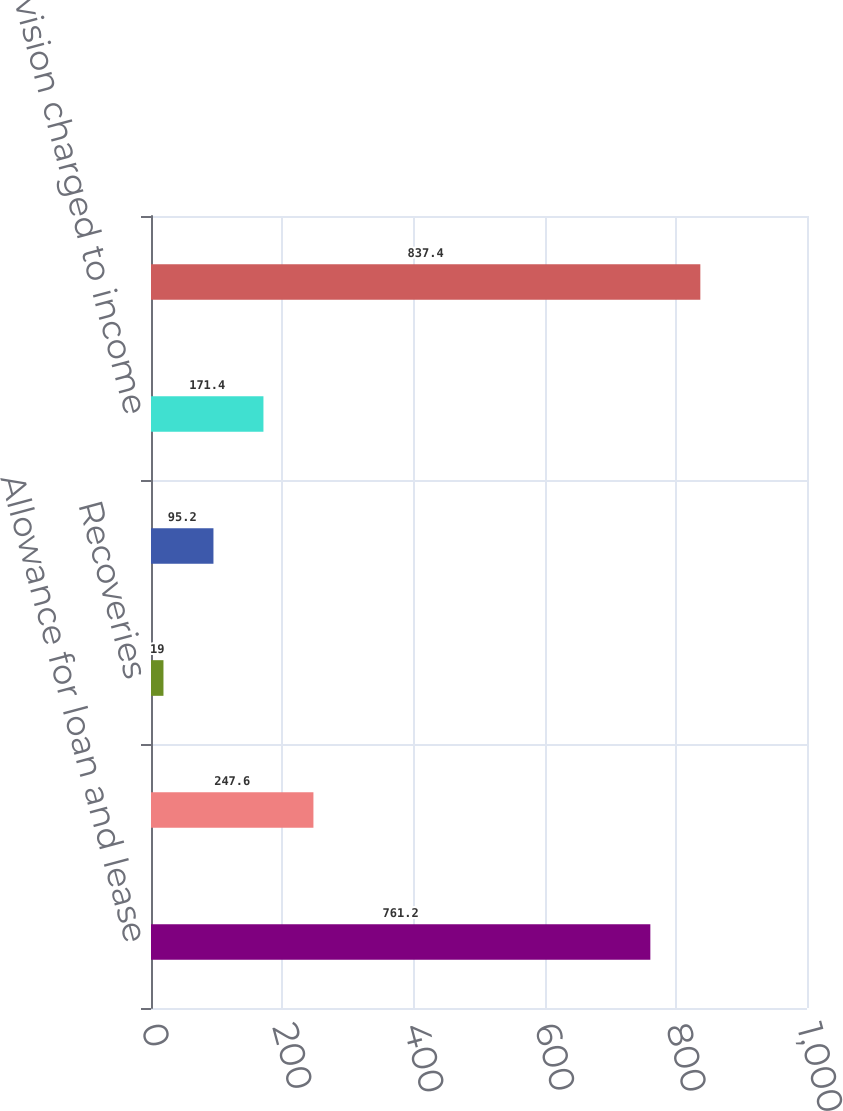<chart> <loc_0><loc_0><loc_500><loc_500><bar_chart><fcel>Allowance for loan and lease<fcel>Charge-offs<fcel>Recoveries<fcel>Net charge-offs<fcel>Provision charged to income<fcel>Total allowance for credit<nl><fcel>761.2<fcel>247.6<fcel>19<fcel>95.2<fcel>171.4<fcel>837.4<nl></chart> 